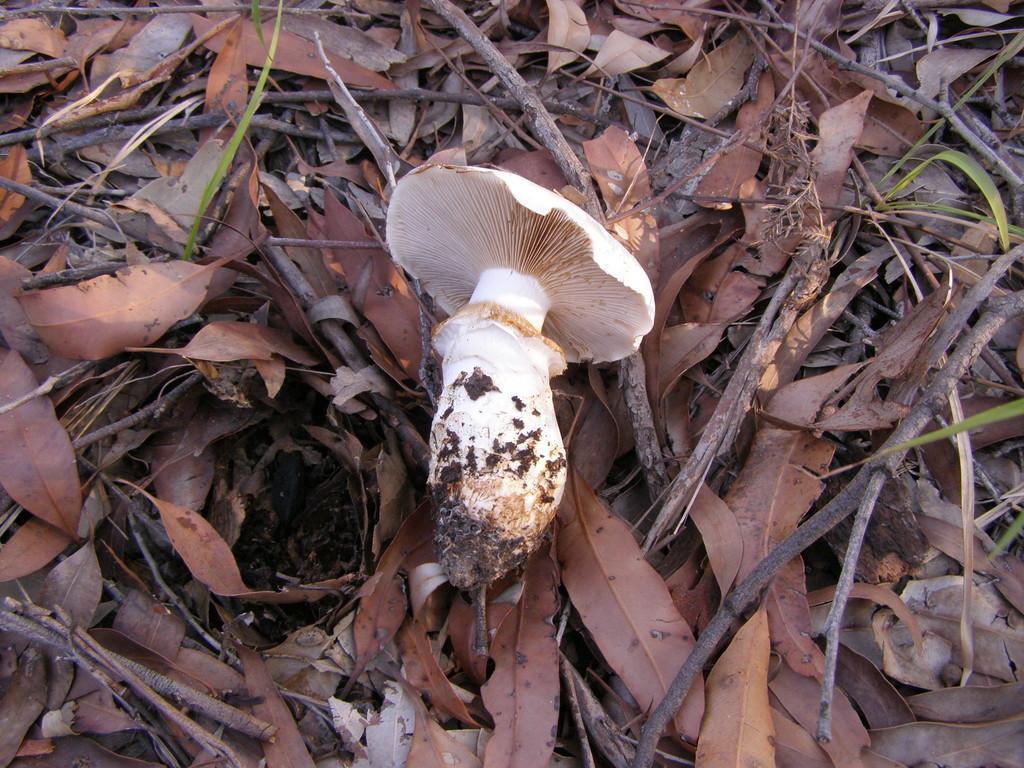Please provide a concise description of this image. In this image, we can see a mushroom, dry leaves, green leaves and twigs. 